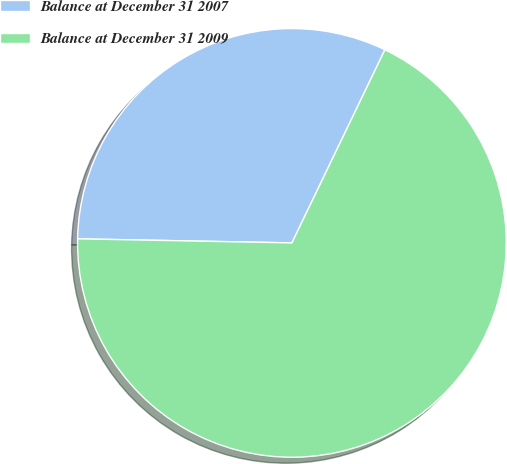Convert chart to OTSL. <chart><loc_0><loc_0><loc_500><loc_500><pie_chart><fcel>Balance at December 31 2007<fcel>Balance at December 31 2009<nl><fcel>31.84%<fcel>68.16%<nl></chart> 